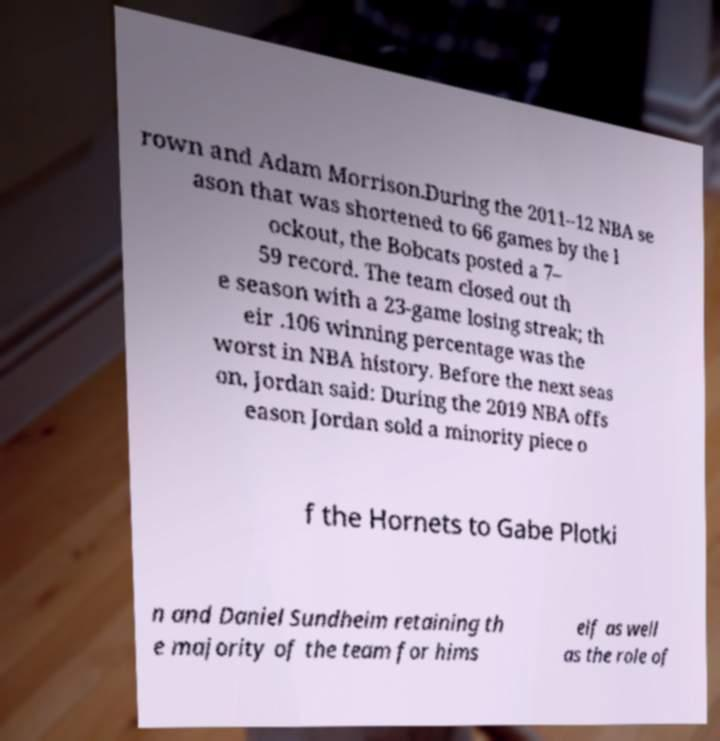Could you assist in decoding the text presented in this image and type it out clearly? rown and Adam Morrison.During the 2011–12 NBA se ason that was shortened to 66 games by the l ockout, the Bobcats posted a 7– 59 record. The team closed out th e season with a 23-game losing streak; th eir .106 winning percentage was the worst in NBA history. Before the next seas on, Jordan said: During the 2019 NBA offs eason Jordan sold a minority piece o f the Hornets to Gabe Plotki n and Daniel Sundheim retaining th e majority of the team for hims elf as well as the role of 